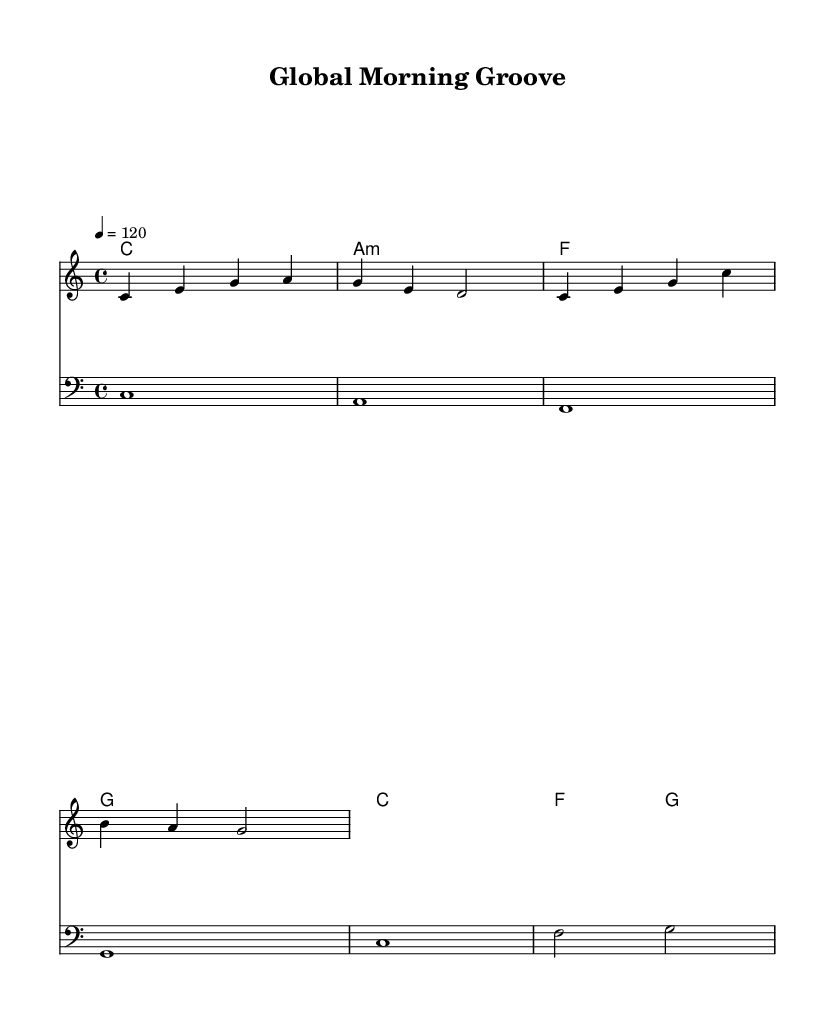What is the key signature of this music? The key signature is C major, which has no sharps or flats.
Answer: C major What is the time signature of this music? The time signature is indicated by the number at the beginning of the score; it shows that there are four beats in each measure.
Answer: 4/4 What is the tempo marking for this piece? The tempo marking is specified as venturing at a speed of 120 beats per minute, which suggests a lively pace.
Answer: 120 How many measures are in the melody? By counting the distinct measures that appear in the melody line, we find there are four measures represented.
Answer: 4 What chord follows the A minor chord in the harmony? The harmony progression indicates that after the A minor chord, the next chord listed is F major.
Answer: F What clef is used for the bass line? The bass line is notated in Bass clef, which is designated for lower pitch ranges in the music.
Answer: Bass clef Which chord appears at the end of the score? The final chord indicated in the chord progression at the end of the piece is G major, completing the harmonic structure.
Answer: G 